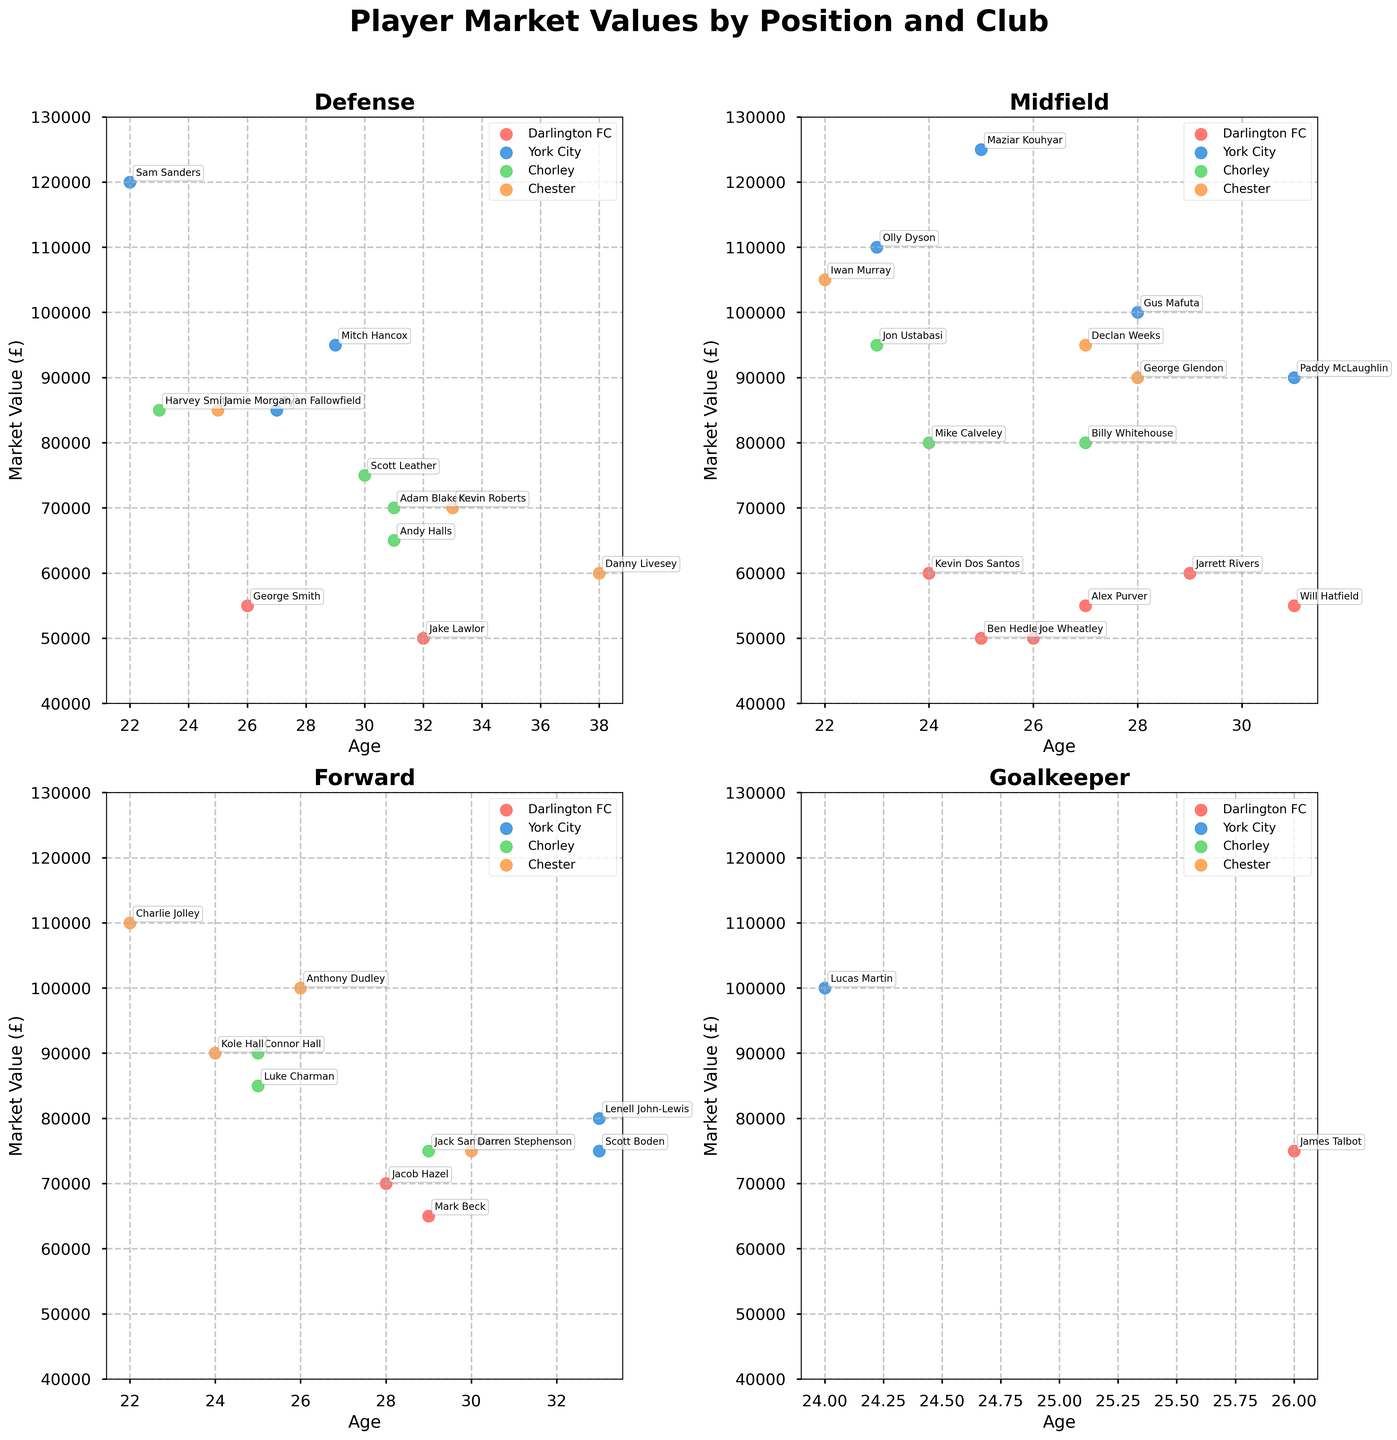What is the highest market value of a Darlington FC player in the Forward position? Look at the subplot titled "Forward" and locate the red dots representing Darlington FC players. Find the highest value on the y-axis among these dots.
Answer: £70,000 Which club has the player with the highest market value in the Goalkeeper position? Check the subplot titled "Goalkeeper" for the highest point on the y-axis. Identify the color corresponding to this dot to determine the club.
Answer: York City Compare the average market values of midfielders (including CM, AM, DM, LW, RW, RM positions) from Darlington FC and Chester. Which club has the higher average market value for midfielders? Calculate the average market value for Darlington FC midfielders by summing their values and dividing by the number of players, do the same for Chester, and then compare. Darlington FC: (£55,000 + £50,000 + £55,000 + £60,000 + £50,000 + £55,000) / 6 = £54,166.67 Chester: (£95,000 + £105,000 + £90,000) / 3 = £96,666.67. Chester has the higher average market value for midfielders.
Answer: Chester In the Defense subplot, which club has the most players aged 30 or above? Look at the subplot titled "Defense" and count the number of dots corresponding to players aged 30 or above for each club.
Answer: Chorley Among the midfielders, which player from York City has the highest market value? In the "Midfield" subplot, find the blue dots and identify the one with the highest y-axis value.
Answer: Maziar Kouhyar 